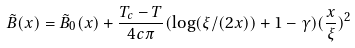<formula> <loc_0><loc_0><loc_500><loc_500>\tilde { B } ( x ) = \tilde { B } _ { 0 } ( x ) + \frac { T _ { c } - T } { 4 c \pi } ( \log ( \xi / ( 2 x ) ) + 1 - \gamma ) ( \frac { x } { \xi } ) ^ { 2 }</formula> 